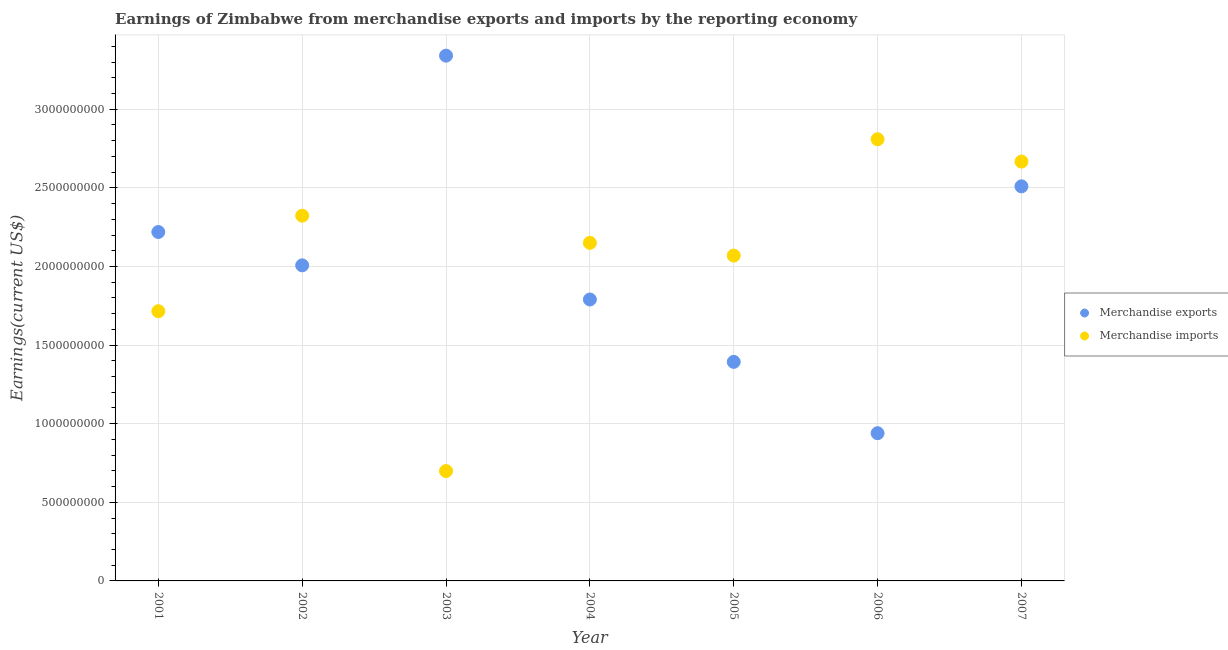How many different coloured dotlines are there?
Your answer should be compact. 2. Is the number of dotlines equal to the number of legend labels?
Your answer should be compact. Yes. What is the earnings from merchandise exports in 2005?
Keep it short and to the point. 1.39e+09. Across all years, what is the maximum earnings from merchandise exports?
Offer a terse response. 3.34e+09. Across all years, what is the minimum earnings from merchandise exports?
Make the answer very short. 9.40e+08. In which year was the earnings from merchandise imports minimum?
Ensure brevity in your answer.  2003. What is the total earnings from merchandise exports in the graph?
Make the answer very short. 1.42e+1. What is the difference between the earnings from merchandise imports in 2002 and that in 2003?
Your response must be concise. 1.62e+09. What is the difference between the earnings from merchandise exports in 2005 and the earnings from merchandise imports in 2004?
Offer a very short reply. -7.57e+08. What is the average earnings from merchandise imports per year?
Give a very brief answer. 2.06e+09. In the year 2005, what is the difference between the earnings from merchandise imports and earnings from merchandise exports?
Your answer should be very brief. 6.76e+08. In how many years, is the earnings from merchandise exports greater than 1900000000 US$?
Offer a very short reply. 4. What is the ratio of the earnings from merchandise imports in 2001 to that in 2003?
Your response must be concise. 2.46. Is the earnings from merchandise imports in 2001 less than that in 2006?
Your answer should be very brief. Yes. What is the difference between the highest and the second highest earnings from merchandise imports?
Your answer should be very brief. 1.42e+08. What is the difference between the highest and the lowest earnings from merchandise exports?
Make the answer very short. 2.40e+09. Is the sum of the earnings from merchandise exports in 2004 and 2006 greater than the maximum earnings from merchandise imports across all years?
Your answer should be very brief. No. Is the earnings from merchandise imports strictly greater than the earnings from merchandise exports over the years?
Your answer should be very brief. No. How many dotlines are there?
Offer a terse response. 2. How many years are there in the graph?
Your answer should be compact. 7. What is the difference between two consecutive major ticks on the Y-axis?
Make the answer very short. 5.00e+08. Does the graph contain any zero values?
Offer a terse response. No. How are the legend labels stacked?
Offer a terse response. Vertical. What is the title of the graph?
Keep it short and to the point. Earnings of Zimbabwe from merchandise exports and imports by the reporting economy. What is the label or title of the Y-axis?
Keep it short and to the point. Earnings(current US$). What is the Earnings(current US$) of Merchandise exports in 2001?
Your answer should be very brief. 2.22e+09. What is the Earnings(current US$) in Merchandise imports in 2001?
Provide a short and direct response. 1.72e+09. What is the Earnings(current US$) in Merchandise exports in 2002?
Your answer should be very brief. 2.01e+09. What is the Earnings(current US$) of Merchandise imports in 2002?
Your answer should be very brief. 2.32e+09. What is the Earnings(current US$) in Merchandise exports in 2003?
Provide a succinct answer. 3.34e+09. What is the Earnings(current US$) in Merchandise imports in 2003?
Your response must be concise. 6.99e+08. What is the Earnings(current US$) in Merchandise exports in 2004?
Give a very brief answer. 1.79e+09. What is the Earnings(current US$) in Merchandise imports in 2004?
Give a very brief answer. 2.15e+09. What is the Earnings(current US$) in Merchandise exports in 2005?
Your answer should be compact. 1.39e+09. What is the Earnings(current US$) of Merchandise imports in 2005?
Offer a very short reply. 2.07e+09. What is the Earnings(current US$) of Merchandise exports in 2006?
Keep it short and to the point. 9.40e+08. What is the Earnings(current US$) in Merchandise imports in 2006?
Your response must be concise. 2.81e+09. What is the Earnings(current US$) of Merchandise exports in 2007?
Your answer should be compact. 2.51e+09. What is the Earnings(current US$) in Merchandise imports in 2007?
Provide a succinct answer. 2.67e+09. Across all years, what is the maximum Earnings(current US$) of Merchandise exports?
Offer a terse response. 3.34e+09. Across all years, what is the maximum Earnings(current US$) of Merchandise imports?
Offer a terse response. 2.81e+09. Across all years, what is the minimum Earnings(current US$) in Merchandise exports?
Offer a terse response. 9.40e+08. Across all years, what is the minimum Earnings(current US$) of Merchandise imports?
Offer a terse response. 6.99e+08. What is the total Earnings(current US$) in Merchandise exports in the graph?
Your response must be concise. 1.42e+1. What is the total Earnings(current US$) of Merchandise imports in the graph?
Your answer should be very brief. 1.44e+1. What is the difference between the Earnings(current US$) in Merchandise exports in 2001 and that in 2002?
Offer a very short reply. 2.12e+08. What is the difference between the Earnings(current US$) in Merchandise imports in 2001 and that in 2002?
Offer a very short reply. -6.07e+08. What is the difference between the Earnings(current US$) of Merchandise exports in 2001 and that in 2003?
Offer a terse response. -1.12e+09. What is the difference between the Earnings(current US$) of Merchandise imports in 2001 and that in 2003?
Offer a very short reply. 1.02e+09. What is the difference between the Earnings(current US$) of Merchandise exports in 2001 and that in 2004?
Provide a succinct answer. 4.29e+08. What is the difference between the Earnings(current US$) in Merchandise imports in 2001 and that in 2004?
Provide a short and direct response. -4.35e+08. What is the difference between the Earnings(current US$) of Merchandise exports in 2001 and that in 2005?
Provide a short and direct response. 8.26e+08. What is the difference between the Earnings(current US$) of Merchandise imports in 2001 and that in 2005?
Offer a very short reply. -3.54e+08. What is the difference between the Earnings(current US$) in Merchandise exports in 2001 and that in 2006?
Keep it short and to the point. 1.28e+09. What is the difference between the Earnings(current US$) in Merchandise imports in 2001 and that in 2006?
Provide a short and direct response. -1.09e+09. What is the difference between the Earnings(current US$) in Merchandise exports in 2001 and that in 2007?
Offer a terse response. -2.91e+08. What is the difference between the Earnings(current US$) of Merchandise imports in 2001 and that in 2007?
Ensure brevity in your answer.  -9.52e+08. What is the difference between the Earnings(current US$) in Merchandise exports in 2002 and that in 2003?
Your answer should be very brief. -1.33e+09. What is the difference between the Earnings(current US$) in Merchandise imports in 2002 and that in 2003?
Offer a very short reply. 1.62e+09. What is the difference between the Earnings(current US$) in Merchandise exports in 2002 and that in 2004?
Your answer should be very brief. 2.17e+08. What is the difference between the Earnings(current US$) of Merchandise imports in 2002 and that in 2004?
Make the answer very short. 1.73e+08. What is the difference between the Earnings(current US$) in Merchandise exports in 2002 and that in 2005?
Ensure brevity in your answer.  6.14e+08. What is the difference between the Earnings(current US$) in Merchandise imports in 2002 and that in 2005?
Offer a very short reply. 2.54e+08. What is the difference between the Earnings(current US$) of Merchandise exports in 2002 and that in 2006?
Provide a succinct answer. 1.07e+09. What is the difference between the Earnings(current US$) of Merchandise imports in 2002 and that in 2006?
Your answer should be compact. -4.86e+08. What is the difference between the Earnings(current US$) of Merchandise exports in 2002 and that in 2007?
Give a very brief answer. -5.03e+08. What is the difference between the Earnings(current US$) in Merchandise imports in 2002 and that in 2007?
Give a very brief answer. -3.44e+08. What is the difference between the Earnings(current US$) in Merchandise exports in 2003 and that in 2004?
Your answer should be compact. 1.55e+09. What is the difference between the Earnings(current US$) in Merchandise imports in 2003 and that in 2004?
Your answer should be very brief. -1.45e+09. What is the difference between the Earnings(current US$) of Merchandise exports in 2003 and that in 2005?
Ensure brevity in your answer.  1.95e+09. What is the difference between the Earnings(current US$) of Merchandise imports in 2003 and that in 2005?
Make the answer very short. -1.37e+09. What is the difference between the Earnings(current US$) of Merchandise exports in 2003 and that in 2006?
Offer a very short reply. 2.40e+09. What is the difference between the Earnings(current US$) of Merchandise imports in 2003 and that in 2006?
Keep it short and to the point. -2.11e+09. What is the difference between the Earnings(current US$) of Merchandise exports in 2003 and that in 2007?
Make the answer very short. 8.31e+08. What is the difference between the Earnings(current US$) in Merchandise imports in 2003 and that in 2007?
Provide a succinct answer. -1.97e+09. What is the difference between the Earnings(current US$) in Merchandise exports in 2004 and that in 2005?
Make the answer very short. 3.97e+08. What is the difference between the Earnings(current US$) in Merchandise imports in 2004 and that in 2005?
Offer a terse response. 8.09e+07. What is the difference between the Earnings(current US$) of Merchandise exports in 2004 and that in 2006?
Give a very brief answer. 8.50e+08. What is the difference between the Earnings(current US$) in Merchandise imports in 2004 and that in 2006?
Give a very brief answer. -6.59e+08. What is the difference between the Earnings(current US$) of Merchandise exports in 2004 and that in 2007?
Your response must be concise. -7.20e+08. What is the difference between the Earnings(current US$) in Merchandise imports in 2004 and that in 2007?
Your answer should be very brief. -5.17e+08. What is the difference between the Earnings(current US$) of Merchandise exports in 2005 and that in 2006?
Provide a succinct answer. 4.54e+08. What is the difference between the Earnings(current US$) of Merchandise imports in 2005 and that in 2006?
Your answer should be very brief. -7.40e+08. What is the difference between the Earnings(current US$) of Merchandise exports in 2005 and that in 2007?
Make the answer very short. -1.12e+09. What is the difference between the Earnings(current US$) of Merchandise imports in 2005 and that in 2007?
Make the answer very short. -5.98e+08. What is the difference between the Earnings(current US$) in Merchandise exports in 2006 and that in 2007?
Offer a terse response. -1.57e+09. What is the difference between the Earnings(current US$) of Merchandise imports in 2006 and that in 2007?
Offer a terse response. 1.42e+08. What is the difference between the Earnings(current US$) of Merchandise exports in 2001 and the Earnings(current US$) of Merchandise imports in 2002?
Provide a short and direct response. -1.04e+08. What is the difference between the Earnings(current US$) in Merchandise exports in 2001 and the Earnings(current US$) in Merchandise imports in 2003?
Offer a terse response. 1.52e+09. What is the difference between the Earnings(current US$) in Merchandise exports in 2001 and the Earnings(current US$) in Merchandise imports in 2004?
Your answer should be compact. 6.91e+07. What is the difference between the Earnings(current US$) of Merchandise exports in 2001 and the Earnings(current US$) of Merchandise imports in 2005?
Offer a terse response. 1.50e+08. What is the difference between the Earnings(current US$) of Merchandise exports in 2001 and the Earnings(current US$) of Merchandise imports in 2006?
Make the answer very short. -5.90e+08. What is the difference between the Earnings(current US$) of Merchandise exports in 2001 and the Earnings(current US$) of Merchandise imports in 2007?
Give a very brief answer. -4.48e+08. What is the difference between the Earnings(current US$) in Merchandise exports in 2002 and the Earnings(current US$) in Merchandise imports in 2003?
Offer a terse response. 1.31e+09. What is the difference between the Earnings(current US$) in Merchandise exports in 2002 and the Earnings(current US$) in Merchandise imports in 2004?
Make the answer very short. -1.43e+08. What is the difference between the Earnings(current US$) in Merchandise exports in 2002 and the Earnings(current US$) in Merchandise imports in 2005?
Keep it short and to the point. -6.21e+07. What is the difference between the Earnings(current US$) in Merchandise exports in 2002 and the Earnings(current US$) in Merchandise imports in 2006?
Provide a short and direct response. -8.02e+08. What is the difference between the Earnings(current US$) in Merchandise exports in 2002 and the Earnings(current US$) in Merchandise imports in 2007?
Ensure brevity in your answer.  -6.60e+08. What is the difference between the Earnings(current US$) of Merchandise exports in 2003 and the Earnings(current US$) of Merchandise imports in 2004?
Offer a terse response. 1.19e+09. What is the difference between the Earnings(current US$) in Merchandise exports in 2003 and the Earnings(current US$) in Merchandise imports in 2005?
Your response must be concise. 1.27e+09. What is the difference between the Earnings(current US$) of Merchandise exports in 2003 and the Earnings(current US$) of Merchandise imports in 2006?
Ensure brevity in your answer.  5.32e+08. What is the difference between the Earnings(current US$) of Merchandise exports in 2003 and the Earnings(current US$) of Merchandise imports in 2007?
Offer a very short reply. 6.74e+08. What is the difference between the Earnings(current US$) of Merchandise exports in 2004 and the Earnings(current US$) of Merchandise imports in 2005?
Ensure brevity in your answer.  -2.79e+08. What is the difference between the Earnings(current US$) in Merchandise exports in 2004 and the Earnings(current US$) in Merchandise imports in 2006?
Provide a succinct answer. -1.02e+09. What is the difference between the Earnings(current US$) in Merchandise exports in 2004 and the Earnings(current US$) in Merchandise imports in 2007?
Make the answer very short. -8.77e+08. What is the difference between the Earnings(current US$) of Merchandise exports in 2005 and the Earnings(current US$) of Merchandise imports in 2006?
Ensure brevity in your answer.  -1.42e+09. What is the difference between the Earnings(current US$) of Merchandise exports in 2005 and the Earnings(current US$) of Merchandise imports in 2007?
Your answer should be compact. -1.27e+09. What is the difference between the Earnings(current US$) of Merchandise exports in 2006 and the Earnings(current US$) of Merchandise imports in 2007?
Make the answer very short. -1.73e+09. What is the average Earnings(current US$) of Merchandise exports per year?
Offer a very short reply. 2.03e+09. What is the average Earnings(current US$) of Merchandise imports per year?
Your answer should be compact. 2.06e+09. In the year 2001, what is the difference between the Earnings(current US$) in Merchandise exports and Earnings(current US$) in Merchandise imports?
Ensure brevity in your answer.  5.04e+08. In the year 2002, what is the difference between the Earnings(current US$) in Merchandise exports and Earnings(current US$) in Merchandise imports?
Keep it short and to the point. -3.16e+08. In the year 2003, what is the difference between the Earnings(current US$) in Merchandise exports and Earnings(current US$) in Merchandise imports?
Your response must be concise. 2.64e+09. In the year 2004, what is the difference between the Earnings(current US$) in Merchandise exports and Earnings(current US$) in Merchandise imports?
Keep it short and to the point. -3.60e+08. In the year 2005, what is the difference between the Earnings(current US$) of Merchandise exports and Earnings(current US$) of Merchandise imports?
Make the answer very short. -6.76e+08. In the year 2006, what is the difference between the Earnings(current US$) in Merchandise exports and Earnings(current US$) in Merchandise imports?
Make the answer very short. -1.87e+09. In the year 2007, what is the difference between the Earnings(current US$) of Merchandise exports and Earnings(current US$) of Merchandise imports?
Provide a succinct answer. -1.57e+08. What is the ratio of the Earnings(current US$) in Merchandise exports in 2001 to that in 2002?
Your answer should be very brief. 1.11. What is the ratio of the Earnings(current US$) of Merchandise imports in 2001 to that in 2002?
Your answer should be very brief. 0.74. What is the ratio of the Earnings(current US$) of Merchandise exports in 2001 to that in 2003?
Your answer should be very brief. 0.66. What is the ratio of the Earnings(current US$) of Merchandise imports in 2001 to that in 2003?
Provide a short and direct response. 2.46. What is the ratio of the Earnings(current US$) in Merchandise exports in 2001 to that in 2004?
Your answer should be very brief. 1.24. What is the ratio of the Earnings(current US$) in Merchandise imports in 2001 to that in 2004?
Your answer should be very brief. 0.8. What is the ratio of the Earnings(current US$) in Merchandise exports in 2001 to that in 2005?
Your answer should be compact. 1.59. What is the ratio of the Earnings(current US$) of Merchandise imports in 2001 to that in 2005?
Give a very brief answer. 0.83. What is the ratio of the Earnings(current US$) of Merchandise exports in 2001 to that in 2006?
Give a very brief answer. 2.36. What is the ratio of the Earnings(current US$) of Merchandise imports in 2001 to that in 2006?
Keep it short and to the point. 0.61. What is the ratio of the Earnings(current US$) of Merchandise exports in 2001 to that in 2007?
Provide a succinct answer. 0.88. What is the ratio of the Earnings(current US$) of Merchandise imports in 2001 to that in 2007?
Provide a succinct answer. 0.64. What is the ratio of the Earnings(current US$) of Merchandise exports in 2002 to that in 2003?
Keep it short and to the point. 0.6. What is the ratio of the Earnings(current US$) of Merchandise imports in 2002 to that in 2003?
Give a very brief answer. 3.32. What is the ratio of the Earnings(current US$) of Merchandise exports in 2002 to that in 2004?
Ensure brevity in your answer.  1.12. What is the ratio of the Earnings(current US$) of Merchandise imports in 2002 to that in 2004?
Ensure brevity in your answer.  1.08. What is the ratio of the Earnings(current US$) of Merchandise exports in 2002 to that in 2005?
Provide a succinct answer. 1.44. What is the ratio of the Earnings(current US$) of Merchandise imports in 2002 to that in 2005?
Your answer should be compact. 1.12. What is the ratio of the Earnings(current US$) of Merchandise exports in 2002 to that in 2006?
Provide a succinct answer. 2.14. What is the ratio of the Earnings(current US$) of Merchandise imports in 2002 to that in 2006?
Offer a very short reply. 0.83. What is the ratio of the Earnings(current US$) in Merchandise exports in 2002 to that in 2007?
Provide a short and direct response. 0.8. What is the ratio of the Earnings(current US$) in Merchandise imports in 2002 to that in 2007?
Offer a very short reply. 0.87. What is the ratio of the Earnings(current US$) in Merchandise exports in 2003 to that in 2004?
Offer a terse response. 1.87. What is the ratio of the Earnings(current US$) of Merchandise imports in 2003 to that in 2004?
Your answer should be very brief. 0.32. What is the ratio of the Earnings(current US$) in Merchandise exports in 2003 to that in 2005?
Ensure brevity in your answer.  2.4. What is the ratio of the Earnings(current US$) in Merchandise imports in 2003 to that in 2005?
Keep it short and to the point. 0.34. What is the ratio of the Earnings(current US$) of Merchandise exports in 2003 to that in 2006?
Offer a terse response. 3.56. What is the ratio of the Earnings(current US$) of Merchandise imports in 2003 to that in 2006?
Your answer should be very brief. 0.25. What is the ratio of the Earnings(current US$) of Merchandise exports in 2003 to that in 2007?
Keep it short and to the point. 1.33. What is the ratio of the Earnings(current US$) of Merchandise imports in 2003 to that in 2007?
Keep it short and to the point. 0.26. What is the ratio of the Earnings(current US$) of Merchandise exports in 2004 to that in 2005?
Offer a very short reply. 1.28. What is the ratio of the Earnings(current US$) of Merchandise imports in 2004 to that in 2005?
Give a very brief answer. 1.04. What is the ratio of the Earnings(current US$) in Merchandise exports in 2004 to that in 2006?
Offer a terse response. 1.91. What is the ratio of the Earnings(current US$) of Merchandise imports in 2004 to that in 2006?
Offer a very short reply. 0.77. What is the ratio of the Earnings(current US$) of Merchandise exports in 2004 to that in 2007?
Provide a short and direct response. 0.71. What is the ratio of the Earnings(current US$) of Merchandise imports in 2004 to that in 2007?
Your answer should be compact. 0.81. What is the ratio of the Earnings(current US$) of Merchandise exports in 2005 to that in 2006?
Provide a short and direct response. 1.48. What is the ratio of the Earnings(current US$) of Merchandise imports in 2005 to that in 2006?
Offer a very short reply. 0.74. What is the ratio of the Earnings(current US$) in Merchandise exports in 2005 to that in 2007?
Make the answer very short. 0.56. What is the ratio of the Earnings(current US$) of Merchandise imports in 2005 to that in 2007?
Provide a succinct answer. 0.78. What is the ratio of the Earnings(current US$) of Merchandise exports in 2006 to that in 2007?
Offer a terse response. 0.37. What is the ratio of the Earnings(current US$) of Merchandise imports in 2006 to that in 2007?
Your response must be concise. 1.05. What is the difference between the highest and the second highest Earnings(current US$) of Merchandise exports?
Your response must be concise. 8.31e+08. What is the difference between the highest and the second highest Earnings(current US$) of Merchandise imports?
Provide a succinct answer. 1.42e+08. What is the difference between the highest and the lowest Earnings(current US$) in Merchandise exports?
Your response must be concise. 2.40e+09. What is the difference between the highest and the lowest Earnings(current US$) of Merchandise imports?
Ensure brevity in your answer.  2.11e+09. 